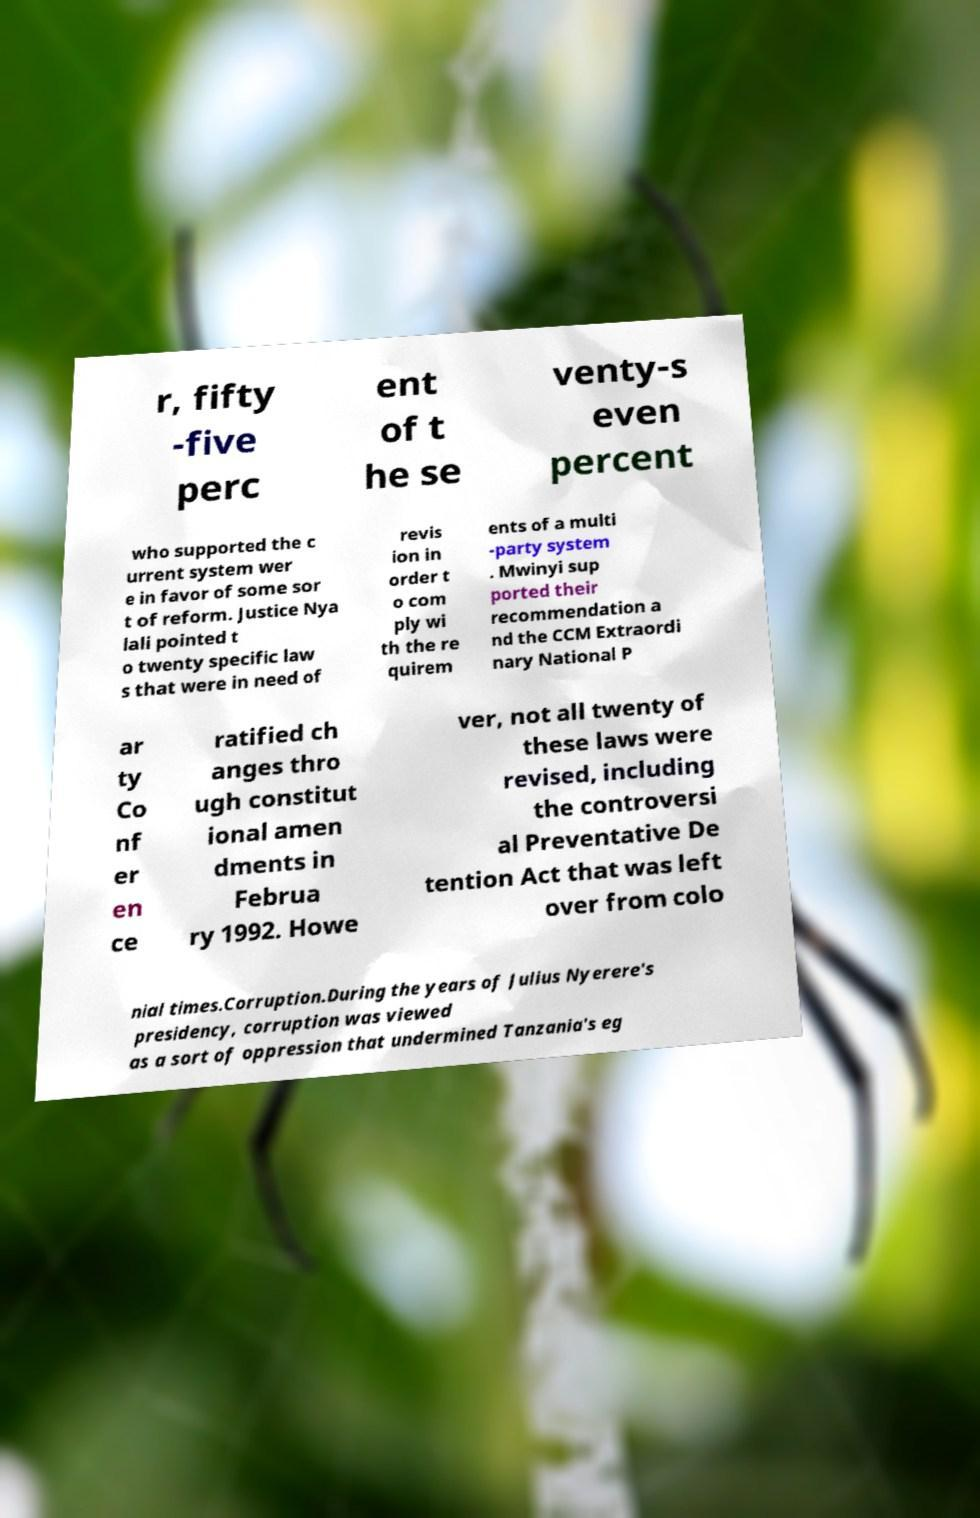I need the written content from this picture converted into text. Can you do that? r, fifty -five perc ent of t he se venty-s even percent who supported the c urrent system wer e in favor of some sor t of reform. Justice Nya lali pointed t o twenty specific law s that were in need of revis ion in order t o com ply wi th the re quirem ents of a multi -party system . Mwinyi sup ported their recommendation a nd the CCM Extraordi nary National P ar ty Co nf er en ce ratified ch anges thro ugh constitut ional amen dments in Februa ry 1992. Howe ver, not all twenty of these laws were revised, including the controversi al Preventative De tention Act that was left over from colo nial times.Corruption.During the years of Julius Nyerere's presidency, corruption was viewed as a sort of oppression that undermined Tanzania's eg 